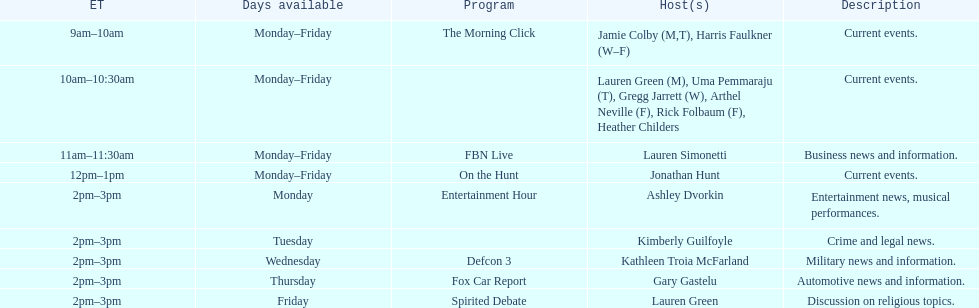What is the length of the defcon 3 show? 1 hour. 